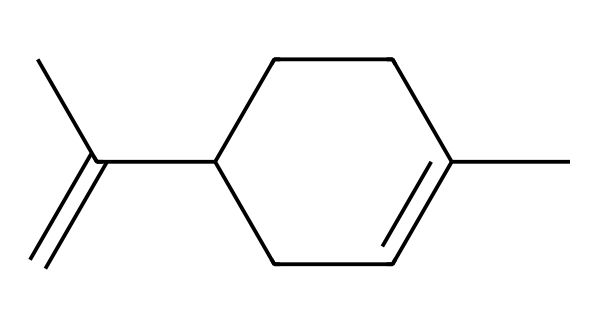What is the name of this chemical? The structure shown corresponds to limonene, which is a terpene commonly found in citrus oils.
Answer: limonene How many carbon atoms are in this chemical? By analyzing the carbon count in the structure, we can see there are ten carbon atoms connected through various bonds.
Answer: ten What type of chemical is limonene classified as? Limonene is classified as a terpene, which is a type of organic compound made of hydrogen and carbon, commonly found in essential oils.
Answer: terpene What is the number of double bonds in limonene's structure? The structure contains two double bonds, which can be observed between the carbon atoms indicated in the carbon chain.
Answer: two Does limonene contain any functional groups? This molecule does not have notable functional groups like alcohol or carboxylic acid; it primarily features carbon and hydrogen atoms.
Answer: no What characteristic scent is associated with limonene? Limonene is typically associated with a citrus scent, as it is commonly found in lemons, oranges, and other citrus fruits.
Answer: citrus 